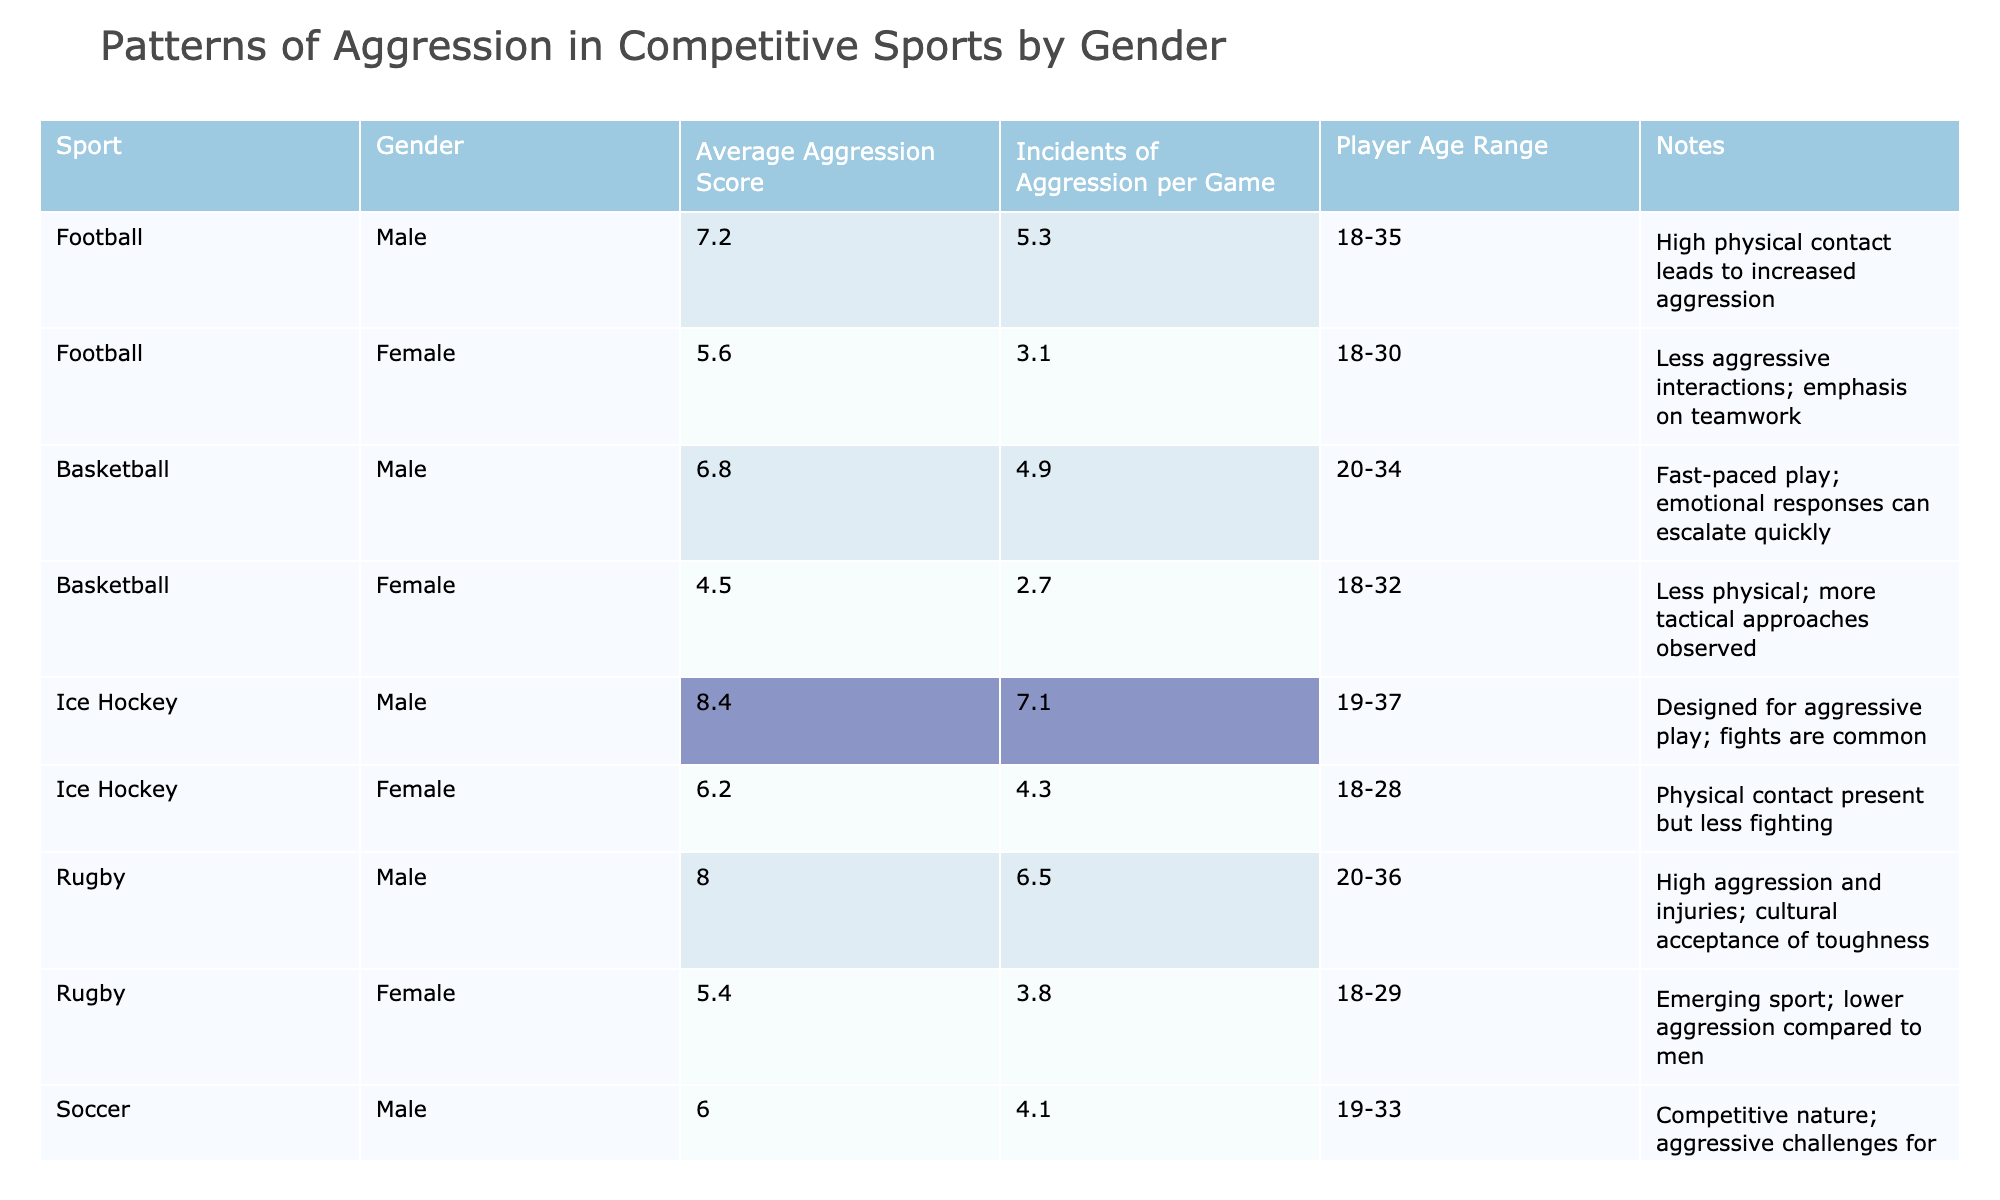What is the average aggression score for male players in Ice Hockey? Referring to the table, the average aggression score for male players in Ice Hockey is highlighted under the corresponding row. It reads 8.4.
Answer: 8.4 Which female sport displays the highest incidents of aggression per game? The table shows the incidents of aggression per game for female players in all sports. The highest value is for Ice Hockey at 4.3.
Answer: 4.3 What is the difference in average aggression scores between male and female players in Rugby? The average aggression score for male players in Rugby is 8.0, while for females it is 5.4. The difference is calculated as 8.0 - 5.4 = 2.6.
Answer: 2.6 Is the average aggression score for female Basketball players higher than that for female Soccer players? The average aggression score for female Basketball players is 4.5, while for female Soccer players it is 4.2. Since 4.5 is greater than 4.2, the statement is true.
Answer: Yes Calculate the average incidents of aggression per game for male players across all sports listed. We sum the incidents of aggression per game for male players: 5.3 (Football) + 4.9 (Basketball) + 7.1 (Ice Hockey) + 6.5 (Rugby) + 4.1 (Soccer) + 5.0 (Taekwondo) = 32.9. There are 6 sports, so the average is 32.9 / 6 = 5.48.
Answer: 5.48 How does the average aggression score for male Football players compare to that of male Taekwondo players? Male Football players have an average aggression score of 7.2, while male Taekwondo players have 7.0. Since 7.2 is higher than 7.0, Football players exhibit greater aggression.
Answer: Yes Which gender and sport combination exhibits the lowest average aggression score? Checking the table, female Soccer players have the lowest average aggression score at 4.2.
Answer: Female Soccer What is the overall trend in aggression scores when comparing male and female players across all sports? By observing the table, male players generally have higher average aggression scores than female players, indicating a trend of increased aggression amongst male players.
Answer: Males generally show higher aggression 